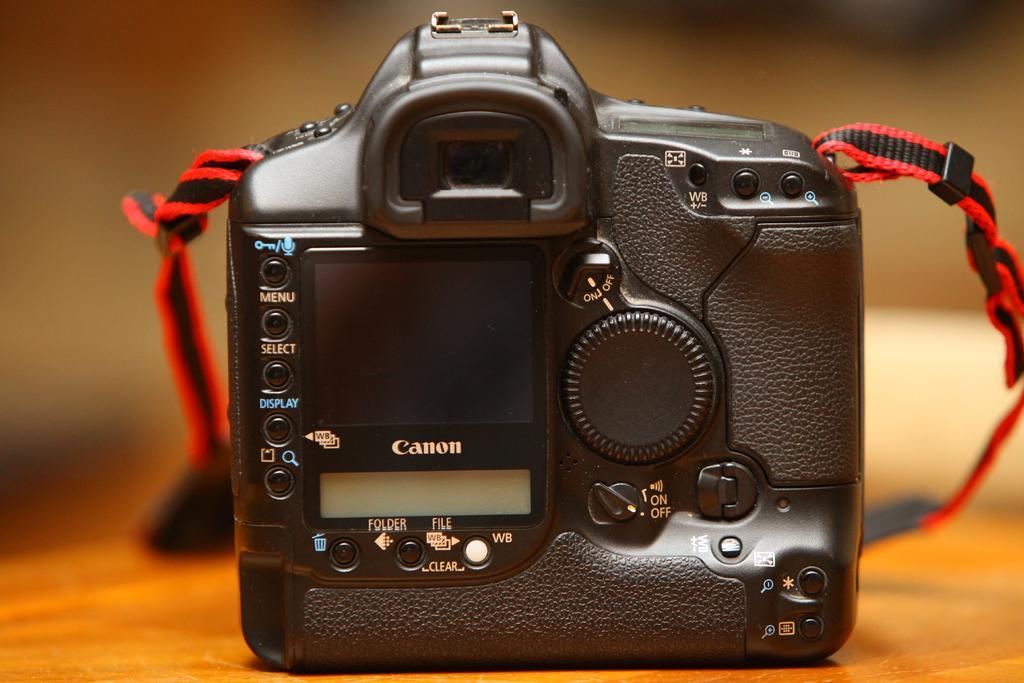How would you summarize this image in a sentence or two? Here we can see a camera on a platform. There is a blur background. 